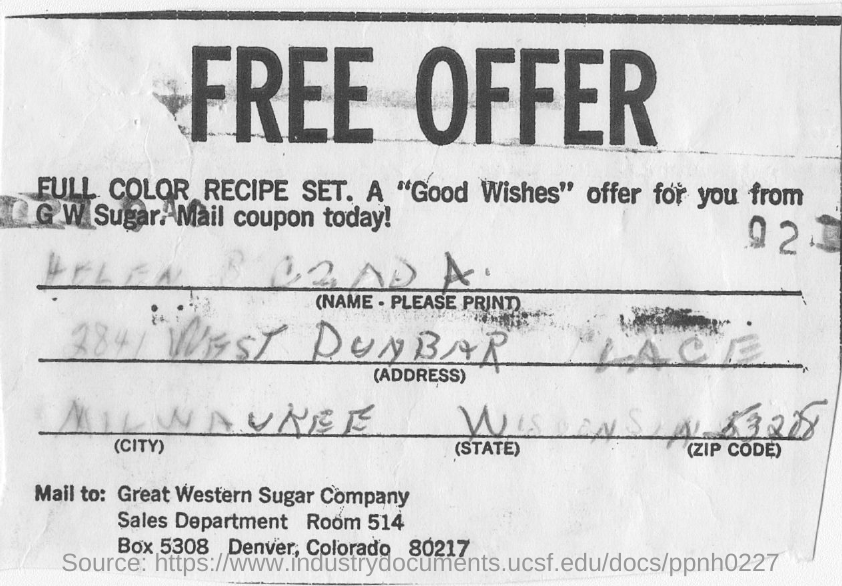Identify some key points in this picture. The Great Western Sugar Company is located in Denver, Colorado, specifically at 80217. The "Good Wishes" offer is from G W Sugar. 